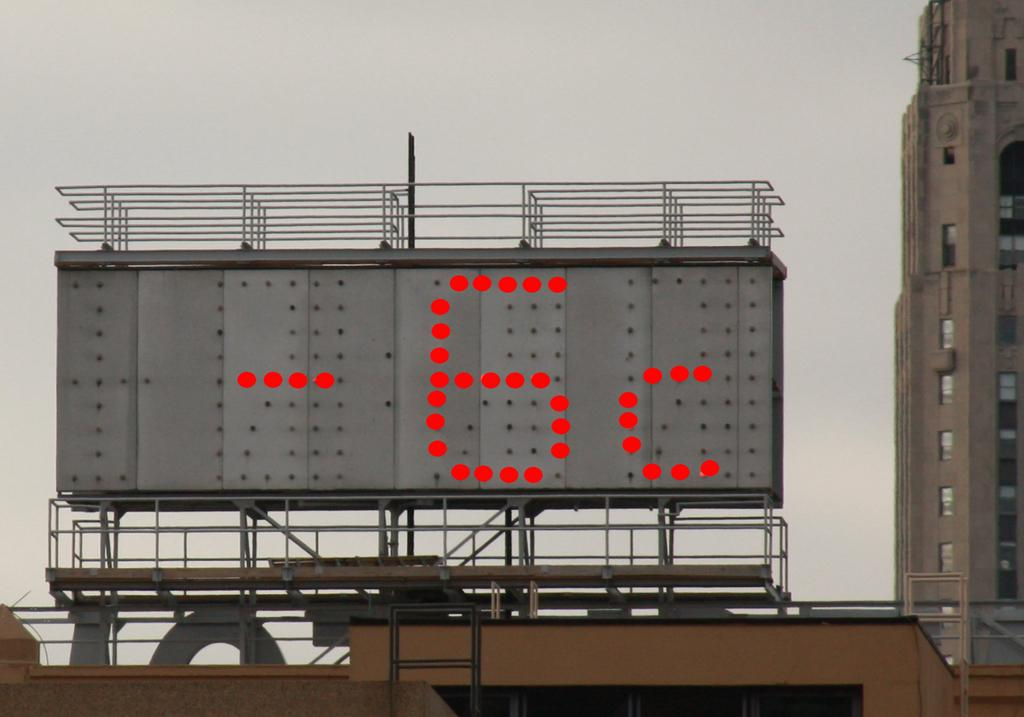<image>
Provide a brief description of the given image. Digital sign reading -6 degrees Celsius on it 